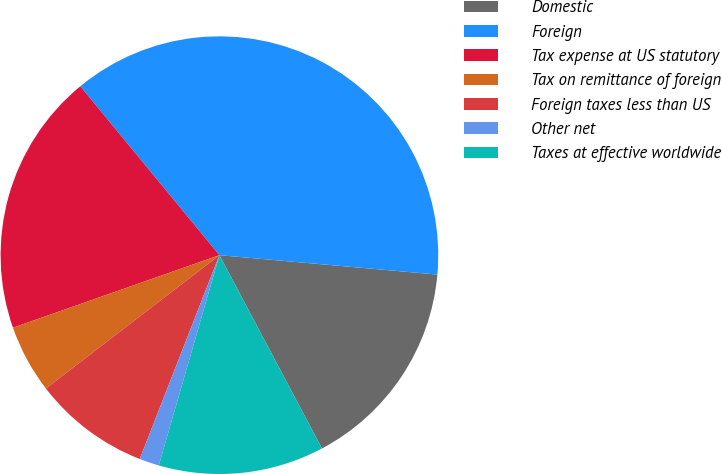<chart> <loc_0><loc_0><loc_500><loc_500><pie_chart><fcel>Domestic<fcel>Foreign<fcel>Tax expense at US statutory<fcel>Tax on remittance of foreign<fcel>Foreign taxes less than US<fcel>Other net<fcel>Taxes at effective worldwide<nl><fcel>15.82%<fcel>37.37%<fcel>19.41%<fcel>5.05%<fcel>8.64%<fcel>1.46%<fcel>12.23%<nl></chart> 